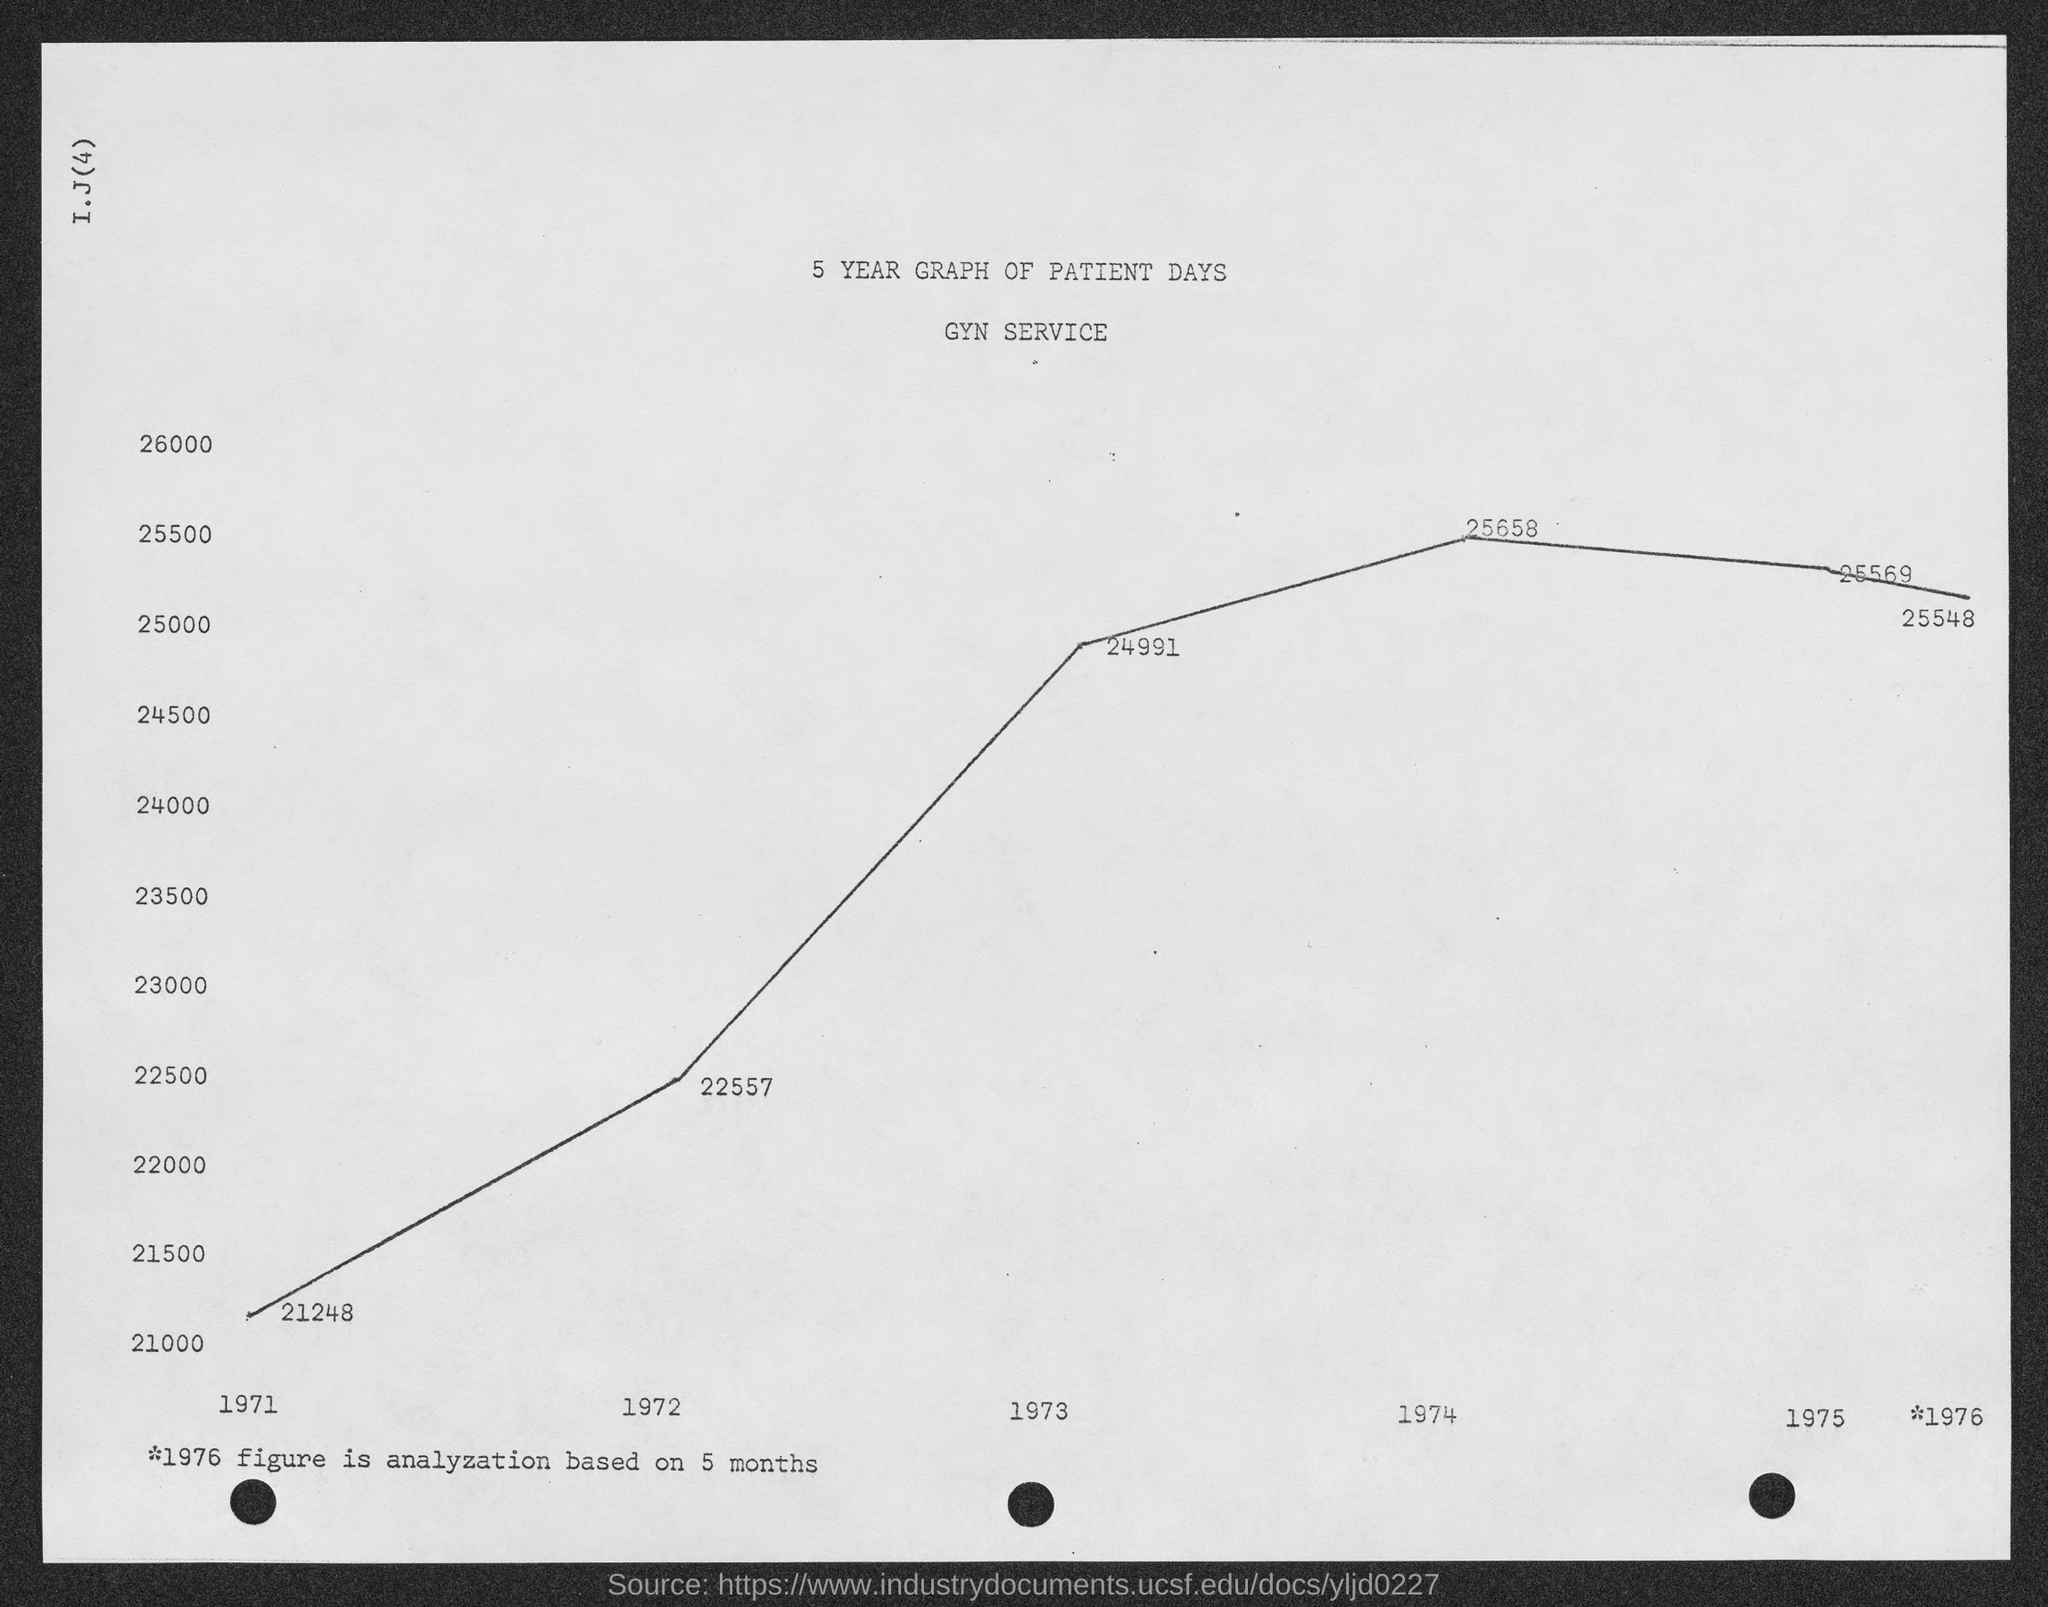List a handful of essential elements in this visual. The amount of patient days in the year 1971 was 21,248. The number of patient days in the year 1975 was 25,569. The amount of patient days in the year 1972 was 22,557. In the year 1973, the total amount of patient days was 24,991. The amount of patient days in the year 1974 was 25,658. 